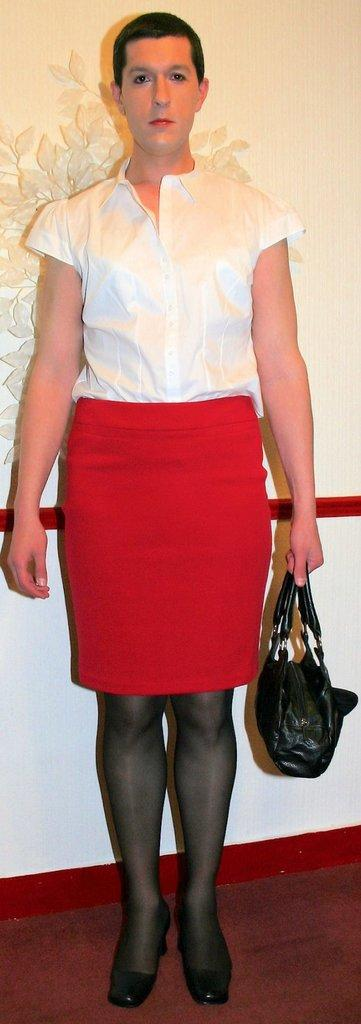Who or what is present in the image? There is a person in the image. What is the person doing in the image? The person is standing. What object is the person holding in the image? The person is holding a handbag. What type of drum can be seen in the image? There is no drum present in the image. How many boats are visible in the image? There are no boats present in the image. 